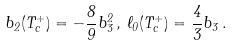Convert formula to latex. <formula><loc_0><loc_0><loc_500><loc_500>b _ { 2 } ( T _ { c } ^ { + } ) = - \frac { 8 } { 9 } b _ { 3 } ^ { 2 } \, , \, \ell _ { 0 } ( T _ { c } ^ { + } ) = \frac { 4 } { 3 } b _ { 3 } \, .</formula> 